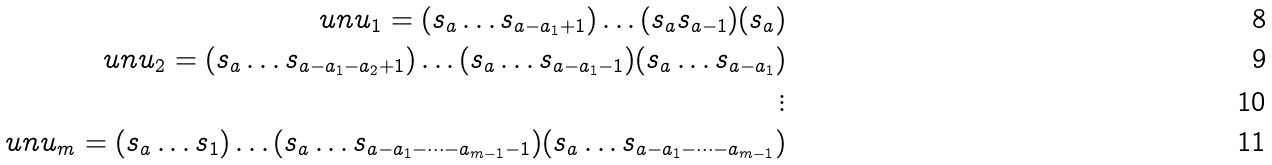<formula> <loc_0><loc_0><loc_500><loc_500>\ u n { u } _ { 1 } = ( s _ { a } \dots s _ { a - a _ { 1 } + 1 } ) \dots ( s _ { a } s _ { a - 1 } ) ( s _ { a } ) \\ \ u n { u } _ { 2 } = ( s _ { a } \dots s _ { a - a _ { 1 } - a _ { 2 } + 1 } ) \dots ( s _ { a } \dots s _ { a - a _ { 1 } - 1 } ) ( s _ { a } \dots s _ { a - a _ { 1 } } ) \\ \vdots \\ \ u n { u } _ { m } = ( s _ { a } \dots s _ { 1 } ) \dots ( s _ { a } \dots s _ { a - a _ { 1 } - \dots - a _ { m - 1 } - 1 } ) ( s _ { a } \dots s _ { a - a _ { 1 } - \dots - a _ { m - 1 } } )</formula> 